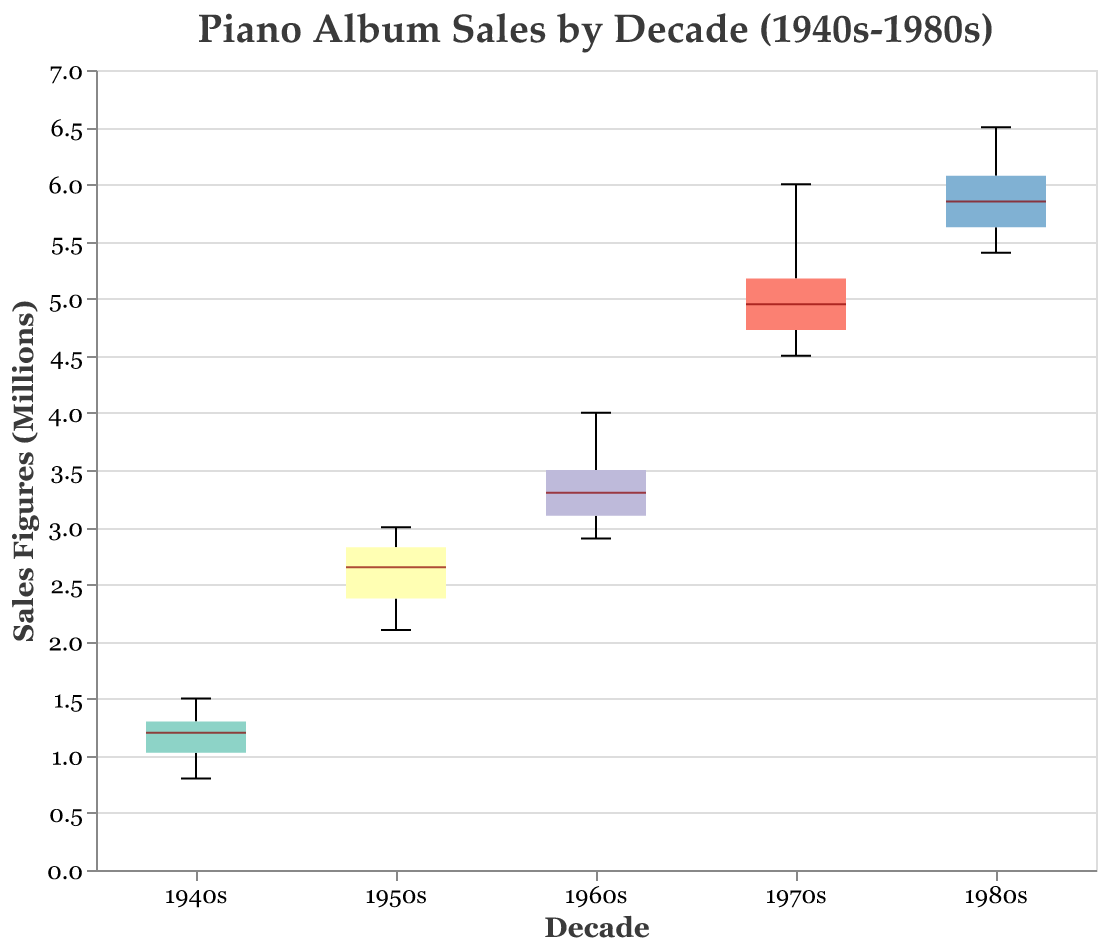What is the title of the box plot? The title of the plot is located at the top of the figure. It usually gives a summary of what the plot is about.
Answer: Piano Album Sales by Decade (1940s-1980s) What is the y-axis title indicating? The y-axis title indicates what is being measured on the vertical axis, which in this case is the sales figures of piano albums in millions.
Answer: Sales Figures (Millions) Which decade has the highest median sales figure? To find the decade with the highest median sales figure, look for the median line (usually a distinct line or color within the box) that is positioned the highest on the y-axis.
Answer: 1980s What is the range of sales figures for albums in the 1960s? To determine the range, look for the lowest and highest points of the box plot for the 1960s. This extends from the smallest to the largest figure within the whiskers (lines extending from the box).
Answer: 2.9 to 4.0 million Compare the interquartile range (IQR) of the 1950s and the 1970s. Which one is larger? The IQR is represented by the height of the box in the box plot. To compare, observe the height of the box in each decade.
Answer: 1970s Are there any outliers in the 1980s sales figures? Outliers in box plots are typically shown as individual points outside the whiskers. Look for any such points in the 1980s data.
Answer: No Which decade has the smallest range in sales figures? The range is the difference between the maximum and minimum values. Examine the length of the whiskers for each decade and identify the shortest one.
Answer: 1940s How much is the median sales figure in the 1970s higher than that in the 1940s? Determine the medians for both decades by observing the central line in each box and then compute the difference between the two.
Answer: 5.0 - 1.2 = 3.8 million Which decade has the most variation in sales figures? The most variation can be identified by looking for the decade with the widest range from minimum to maximum sales figures (length of the whiskers plus the range within the box).
Answer: 1980s How do the upper quartiles of the 1960s and the 1980s compare? The upper quartile is represented by the top of the box. Compare the height position of the top of the boxes of the 1960s and 1980s.
Answer: 1980s has a higher upper quartile 